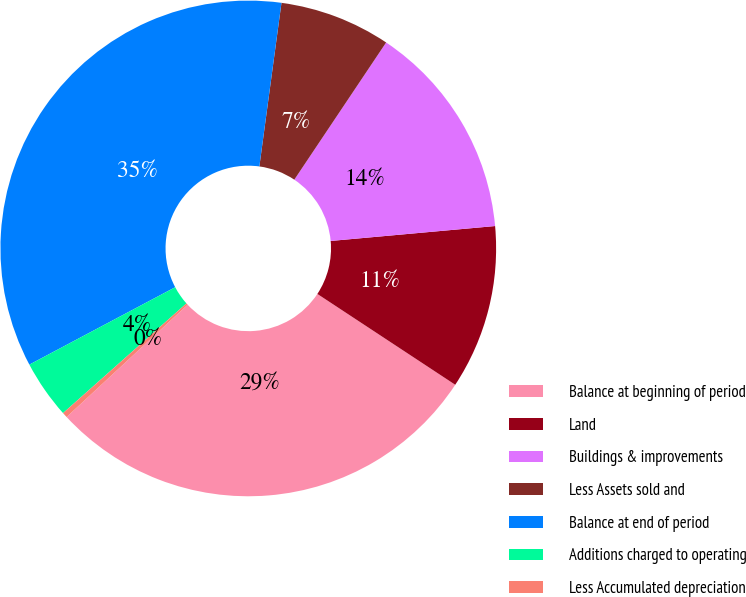<chart> <loc_0><loc_0><loc_500><loc_500><pie_chart><fcel>Balance at beginning of period<fcel>Land<fcel>Buildings & improvements<fcel>Less Assets sold and<fcel>Balance at end of period<fcel>Additions charged to operating<fcel>Less Accumulated depreciation<nl><fcel>28.82%<fcel>10.71%<fcel>14.17%<fcel>7.25%<fcel>34.9%<fcel>3.8%<fcel>0.34%<nl></chart> 